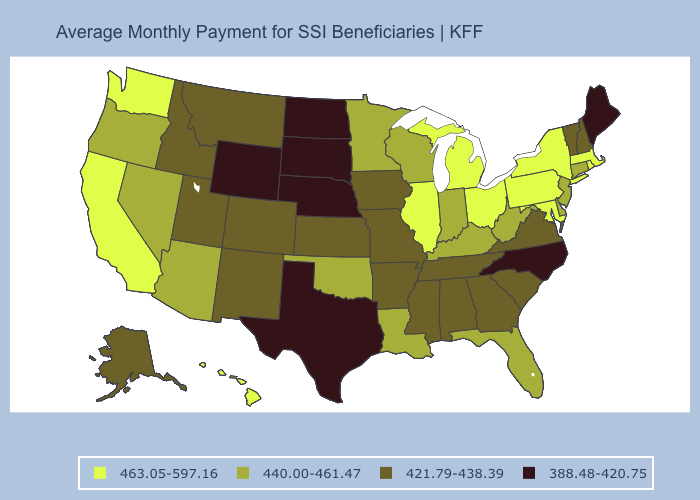Name the states that have a value in the range 463.05-597.16?
Keep it brief. California, Hawaii, Illinois, Maryland, Massachusetts, Michigan, New York, Ohio, Pennsylvania, Rhode Island, Washington. Which states have the highest value in the USA?
Write a very short answer. California, Hawaii, Illinois, Maryland, Massachusetts, Michigan, New York, Ohio, Pennsylvania, Rhode Island, Washington. Name the states that have a value in the range 421.79-438.39?
Keep it brief. Alabama, Alaska, Arkansas, Colorado, Georgia, Idaho, Iowa, Kansas, Mississippi, Missouri, Montana, New Hampshire, New Mexico, South Carolina, Tennessee, Utah, Vermont, Virginia. What is the value of Hawaii?
Be succinct. 463.05-597.16. What is the value of Texas?
Give a very brief answer. 388.48-420.75. What is the value of Maine?
Be succinct. 388.48-420.75. How many symbols are there in the legend?
Give a very brief answer. 4. Among the states that border Virginia , does West Virginia have the highest value?
Answer briefly. No. Does the first symbol in the legend represent the smallest category?
Quick response, please. No. Name the states that have a value in the range 421.79-438.39?
Concise answer only. Alabama, Alaska, Arkansas, Colorado, Georgia, Idaho, Iowa, Kansas, Mississippi, Missouri, Montana, New Hampshire, New Mexico, South Carolina, Tennessee, Utah, Vermont, Virginia. What is the lowest value in states that border Virginia?
Answer briefly. 388.48-420.75. Among the states that border Utah , which have the highest value?
Give a very brief answer. Arizona, Nevada. Name the states that have a value in the range 388.48-420.75?
Quick response, please. Maine, Nebraska, North Carolina, North Dakota, South Dakota, Texas, Wyoming. What is the lowest value in the West?
Keep it brief. 388.48-420.75. Name the states that have a value in the range 421.79-438.39?
Concise answer only. Alabama, Alaska, Arkansas, Colorado, Georgia, Idaho, Iowa, Kansas, Mississippi, Missouri, Montana, New Hampshire, New Mexico, South Carolina, Tennessee, Utah, Vermont, Virginia. 